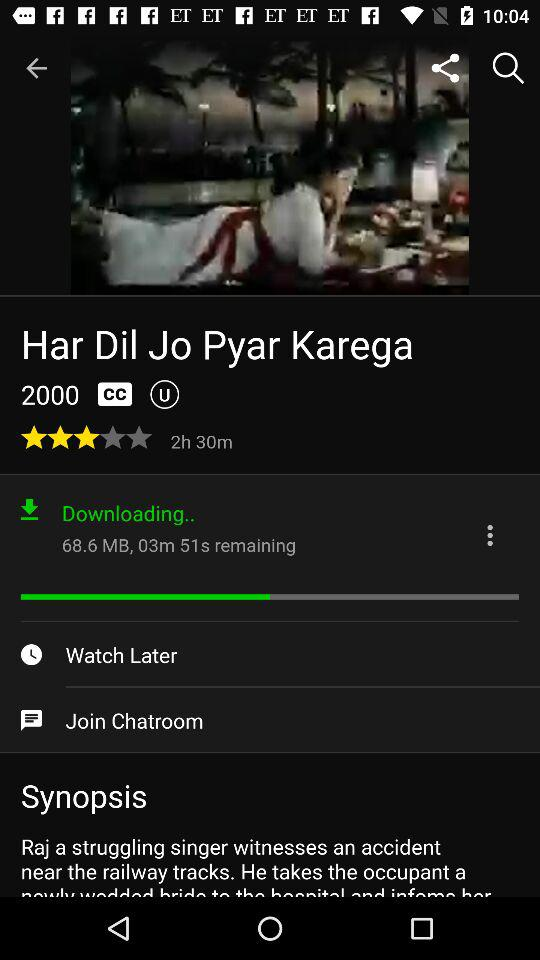How many stars are given to the movie "Har Dil Jo Pyar Karega"? There are 3 stars given. 